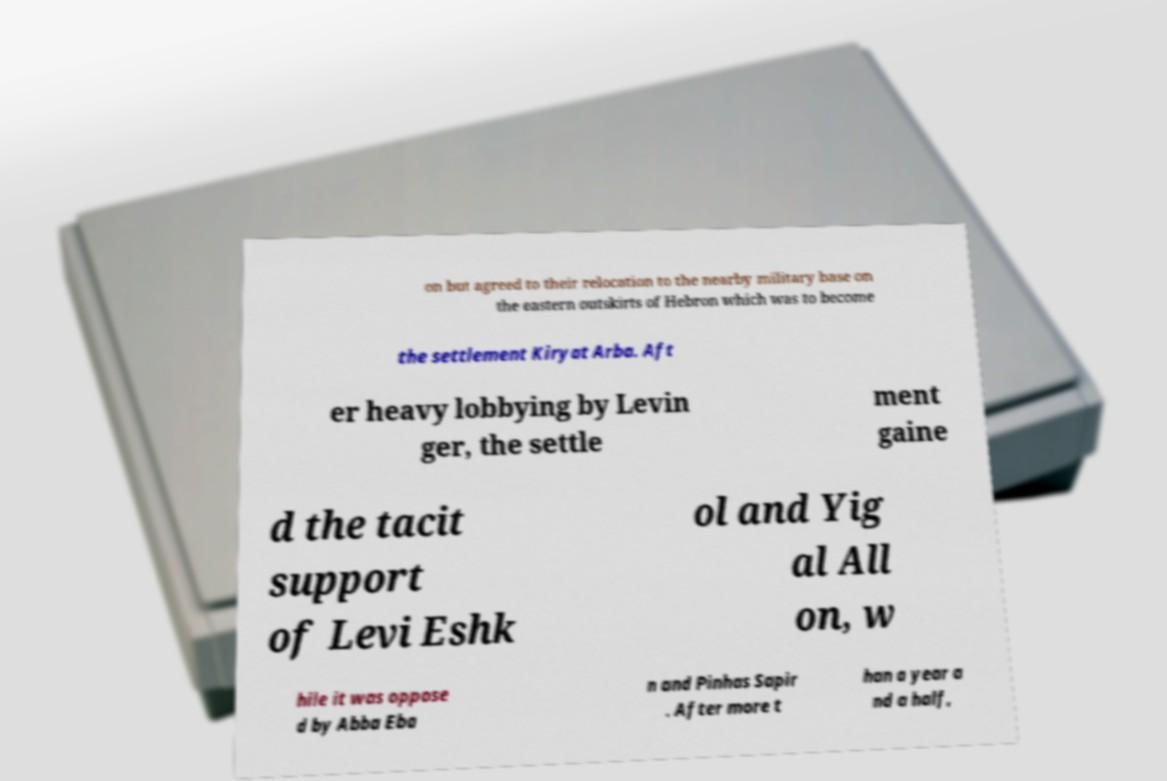Please identify and transcribe the text found in this image. on but agreed to their relocation to the nearby military base on the eastern outskirts of Hebron which was to become the settlement Kiryat Arba. Aft er heavy lobbying by Levin ger, the settle ment gaine d the tacit support of Levi Eshk ol and Yig al All on, w hile it was oppose d by Abba Eba n and Pinhas Sapir . After more t han a year a nd a half, 